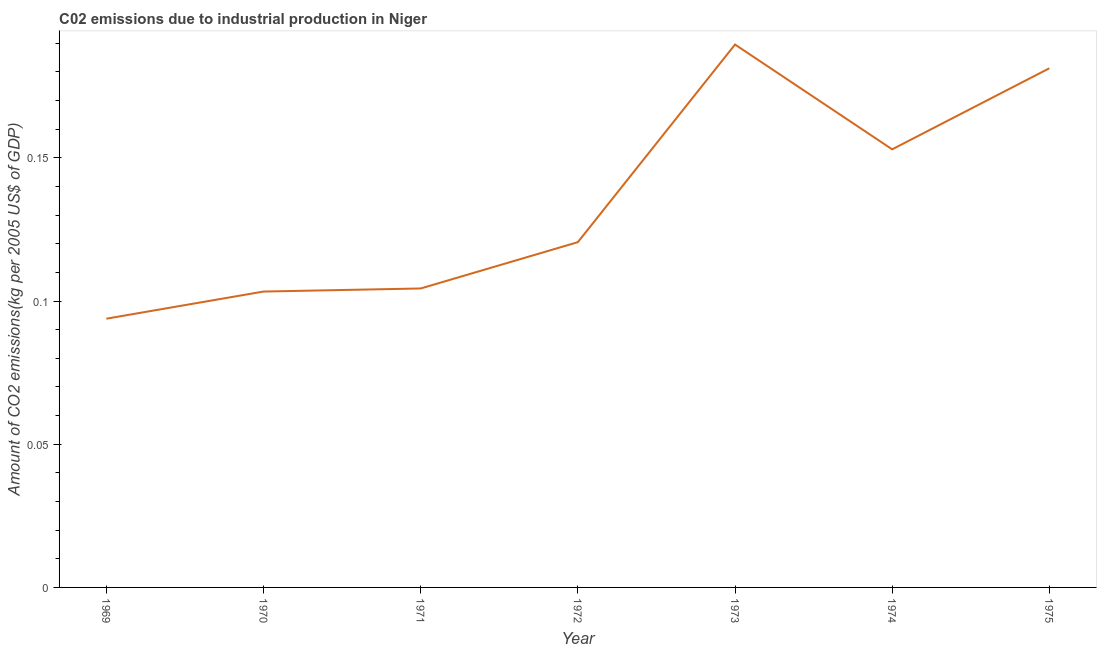What is the amount of co2 emissions in 1975?
Give a very brief answer. 0.18. Across all years, what is the maximum amount of co2 emissions?
Give a very brief answer. 0.19. Across all years, what is the minimum amount of co2 emissions?
Provide a short and direct response. 0.09. In which year was the amount of co2 emissions minimum?
Provide a succinct answer. 1969. What is the sum of the amount of co2 emissions?
Offer a very short reply. 0.95. What is the difference between the amount of co2 emissions in 1970 and 1975?
Offer a very short reply. -0.08. What is the average amount of co2 emissions per year?
Make the answer very short. 0.14. What is the median amount of co2 emissions?
Your answer should be compact. 0.12. Do a majority of the years between 1970 and 1969 (inclusive) have amount of co2 emissions greater than 0.03 kg per 2005 US$ of GDP?
Provide a succinct answer. No. What is the ratio of the amount of co2 emissions in 1971 to that in 1973?
Keep it short and to the point. 0.55. What is the difference between the highest and the second highest amount of co2 emissions?
Offer a very short reply. 0.01. What is the difference between the highest and the lowest amount of co2 emissions?
Your response must be concise. 0.1. In how many years, is the amount of co2 emissions greater than the average amount of co2 emissions taken over all years?
Provide a short and direct response. 3. How many lines are there?
Ensure brevity in your answer.  1. What is the difference between two consecutive major ticks on the Y-axis?
Provide a succinct answer. 0.05. Does the graph contain any zero values?
Offer a very short reply. No. Does the graph contain grids?
Provide a short and direct response. No. What is the title of the graph?
Offer a terse response. C02 emissions due to industrial production in Niger. What is the label or title of the Y-axis?
Provide a succinct answer. Amount of CO2 emissions(kg per 2005 US$ of GDP). What is the Amount of CO2 emissions(kg per 2005 US$ of GDP) in 1969?
Give a very brief answer. 0.09. What is the Amount of CO2 emissions(kg per 2005 US$ of GDP) of 1970?
Your answer should be very brief. 0.1. What is the Amount of CO2 emissions(kg per 2005 US$ of GDP) in 1971?
Your answer should be compact. 0.1. What is the Amount of CO2 emissions(kg per 2005 US$ of GDP) in 1972?
Give a very brief answer. 0.12. What is the Amount of CO2 emissions(kg per 2005 US$ of GDP) of 1973?
Offer a very short reply. 0.19. What is the Amount of CO2 emissions(kg per 2005 US$ of GDP) of 1974?
Give a very brief answer. 0.15. What is the Amount of CO2 emissions(kg per 2005 US$ of GDP) in 1975?
Offer a terse response. 0.18. What is the difference between the Amount of CO2 emissions(kg per 2005 US$ of GDP) in 1969 and 1970?
Keep it short and to the point. -0.01. What is the difference between the Amount of CO2 emissions(kg per 2005 US$ of GDP) in 1969 and 1971?
Provide a short and direct response. -0.01. What is the difference between the Amount of CO2 emissions(kg per 2005 US$ of GDP) in 1969 and 1972?
Ensure brevity in your answer.  -0.03. What is the difference between the Amount of CO2 emissions(kg per 2005 US$ of GDP) in 1969 and 1973?
Your response must be concise. -0.1. What is the difference between the Amount of CO2 emissions(kg per 2005 US$ of GDP) in 1969 and 1974?
Your response must be concise. -0.06. What is the difference between the Amount of CO2 emissions(kg per 2005 US$ of GDP) in 1969 and 1975?
Your response must be concise. -0.09. What is the difference between the Amount of CO2 emissions(kg per 2005 US$ of GDP) in 1970 and 1971?
Offer a terse response. -0. What is the difference between the Amount of CO2 emissions(kg per 2005 US$ of GDP) in 1970 and 1972?
Make the answer very short. -0.02. What is the difference between the Amount of CO2 emissions(kg per 2005 US$ of GDP) in 1970 and 1973?
Give a very brief answer. -0.09. What is the difference between the Amount of CO2 emissions(kg per 2005 US$ of GDP) in 1970 and 1974?
Provide a short and direct response. -0.05. What is the difference between the Amount of CO2 emissions(kg per 2005 US$ of GDP) in 1970 and 1975?
Provide a short and direct response. -0.08. What is the difference between the Amount of CO2 emissions(kg per 2005 US$ of GDP) in 1971 and 1972?
Provide a succinct answer. -0.02. What is the difference between the Amount of CO2 emissions(kg per 2005 US$ of GDP) in 1971 and 1973?
Your answer should be compact. -0.09. What is the difference between the Amount of CO2 emissions(kg per 2005 US$ of GDP) in 1971 and 1974?
Your answer should be compact. -0.05. What is the difference between the Amount of CO2 emissions(kg per 2005 US$ of GDP) in 1971 and 1975?
Ensure brevity in your answer.  -0.08. What is the difference between the Amount of CO2 emissions(kg per 2005 US$ of GDP) in 1972 and 1973?
Your response must be concise. -0.07. What is the difference between the Amount of CO2 emissions(kg per 2005 US$ of GDP) in 1972 and 1974?
Your answer should be very brief. -0.03. What is the difference between the Amount of CO2 emissions(kg per 2005 US$ of GDP) in 1972 and 1975?
Offer a very short reply. -0.06. What is the difference between the Amount of CO2 emissions(kg per 2005 US$ of GDP) in 1973 and 1974?
Give a very brief answer. 0.04. What is the difference between the Amount of CO2 emissions(kg per 2005 US$ of GDP) in 1973 and 1975?
Keep it short and to the point. 0.01. What is the difference between the Amount of CO2 emissions(kg per 2005 US$ of GDP) in 1974 and 1975?
Keep it short and to the point. -0.03. What is the ratio of the Amount of CO2 emissions(kg per 2005 US$ of GDP) in 1969 to that in 1970?
Ensure brevity in your answer.  0.91. What is the ratio of the Amount of CO2 emissions(kg per 2005 US$ of GDP) in 1969 to that in 1971?
Give a very brief answer. 0.9. What is the ratio of the Amount of CO2 emissions(kg per 2005 US$ of GDP) in 1969 to that in 1972?
Ensure brevity in your answer.  0.78. What is the ratio of the Amount of CO2 emissions(kg per 2005 US$ of GDP) in 1969 to that in 1973?
Offer a terse response. 0.49. What is the ratio of the Amount of CO2 emissions(kg per 2005 US$ of GDP) in 1969 to that in 1974?
Your response must be concise. 0.61. What is the ratio of the Amount of CO2 emissions(kg per 2005 US$ of GDP) in 1969 to that in 1975?
Make the answer very short. 0.52. What is the ratio of the Amount of CO2 emissions(kg per 2005 US$ of GDP) in 1970 to that in 1972?
Your answer should be very brief. 0.86. What is the ratio of the Amount of CO2 emissions(kg per 2005 US$ of GDP) in 1970 to that in 1973?
Ensure brevity in your answer.  0.55. What is the ratio of the Amount of CO2 emissions(kg per 2005 US$ of GDP) in 1970 to that in 1974?
Your answer should be very brief. 0.68. What is the ratio of the Amount of CO2 emissions(kg per 2005 US$ of GDP) in 1970 to that in 1975?
Offer a terse response. 0.57. What is the ratio of the Amount of CO2 emissions(kg per 2005 US$ of GDP) in 1971 to that in 1972?
Your answer should be compact. 0.87. What is the ratio of the Amount of CO2 emissions(kg per 2005 US$ of GDP) in 1971 to that in 1973?
Give a very brief answer. 0.55. What is the ratio of the Amount of CO2 emissions(kg per 2005 US$ of GDP) in 1971 to that in 1974?
Your answer should be compact. 0.68. What is the ratio of the Amount of CO2 emissions(kg per 2005 US$ of GDP) in 1971 to that in 1975?
Give a very brief answer. 0.58. What is the ratio of the Amount of CO2 emissions(kg per 2005 US$ of GDP) in 1972 to that in 1973?
Ensure brevity in your answer.  0.64. What is the ratio of the Amount of CO2 emissions(kg per 2005 US$ of GDP) in 1972 to that in 1974?
Your answer should be very brief. 0.79. What is the ratio of the Amount of CO2 emissions(kg per 2005 US$ of GDP) in 1972 to that in 1975?
Ensure brevity in your answer.  0.67. What is the ratio of the Amount of CO2 emissions(kg per 2005 US$ of GDP) in 1973 to that in 1974?
Make the answer very short. 1.24. What is the ratio of the Amount of CO2 emissions(kg per 2005 US$ of GDP) in 1973 to that in 1975?
Offer a terse response. 1.05. What is the ratio of the Amount of CO2 emissions(kg per 2005 US$ of GDP) in 1974 to that in 1975?
Provide a succinct answer. 0.84. 